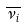Convert formula to latex. <formula><loc_0><loc_0><loc_500><loc_500>\overline { \nu _ { i } }</formula> 